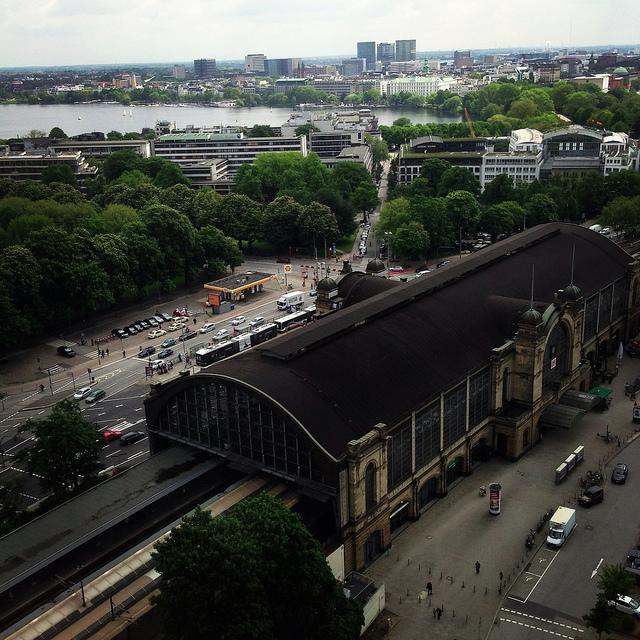The orange rimmed building probable sells which of these products? gas 